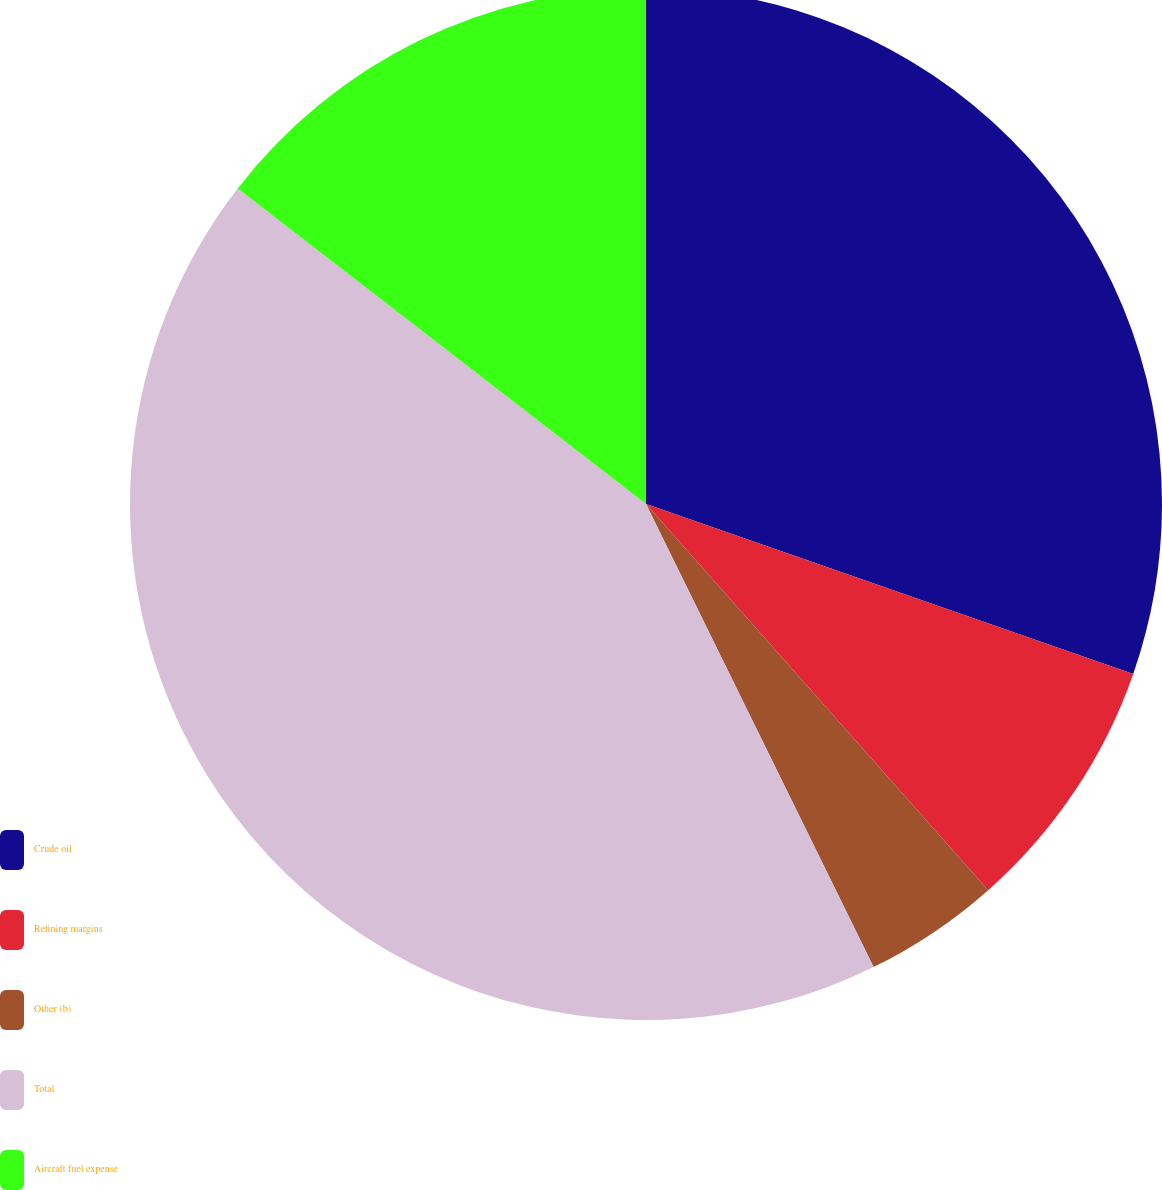<chart> <loc_0><loc_0><loc_500><loc_500><pie_chart><fcel>Crude oil<fcel>Refining margins<fcel>Other (b)<fcel>Total<fcel>Aircraft fuel expense<nl><fcel>30.34%<fcel>8.12%<fcel>4.27%<fcel>42.74%<fcel>14.53%<nl></chart> 